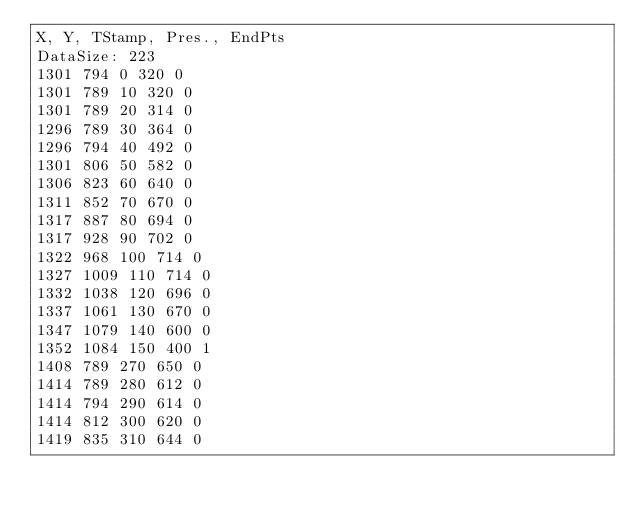Convert code to text. <code><loc_0><loc_0><loc_500><loc_500><_SML_>X, Y, TStamp, Pres., EndPts
DataSize: 223
1301 794 0 320 0
1301 789 10 320 0
1301 789 20 314 0
1296 789 30 364 0
1296 794 40 492 0
1301 806 50 582 0
1306 823 60 640 0
1311 852 70 670 0
1317 887 80 694 0
1317 928 90 702 0
1322 968 100 714 0
1327 1009 110 714 0
1332 1038 120 696 0
1337 1061 130 670 0
1347 1079 140 600 0
1352 1084 150 400 1
1408 789 270 650 0
1414 789 280 612 0
1414 794 290 614 0
1414 812 300 620 0
1419 835 310 644 0</code> 